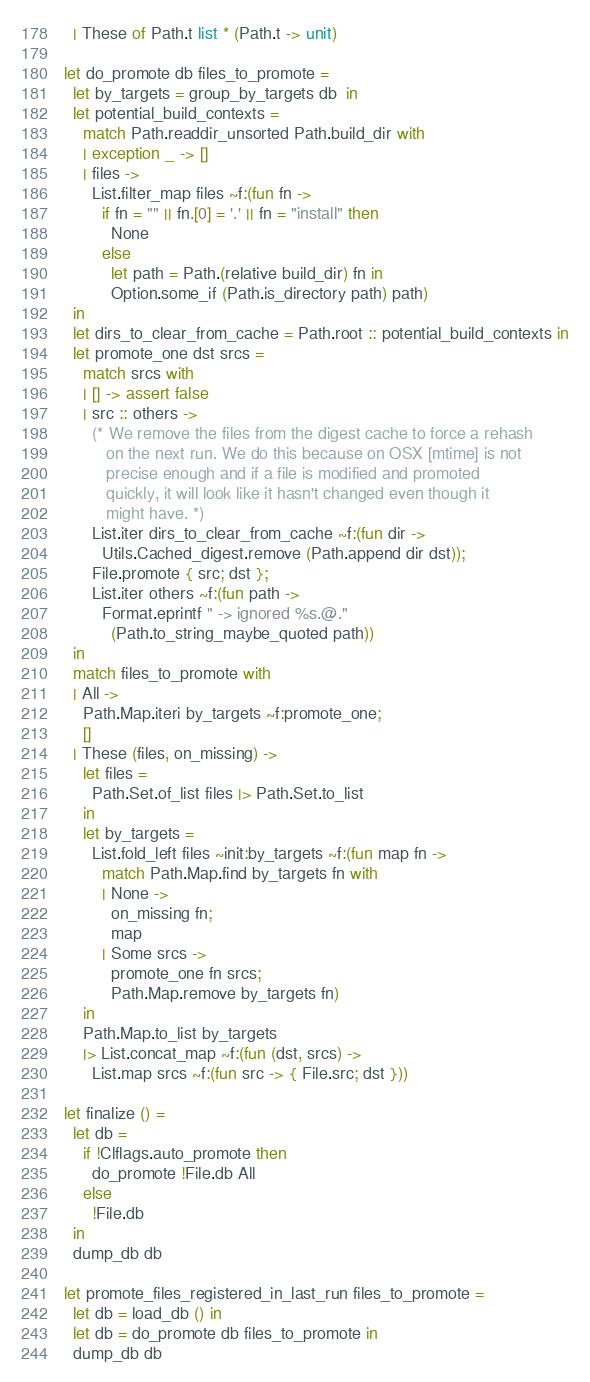<code> <loc_0><loc_0><loc_500><loc_500><_OCaml_>  | These of Path.t list * (Path.t -> unit)

let do_promote db files_to_promote =
  let by_targets = group_by_targets db  in
  let potential_build_contexts =
    match Path.readdir_unsorted Path.build_dir with
    | exception _ -> []
    | files ->
      List.filter_map files ~f:(fun fn ->
        if fn = "" || fn.[0] = '.' || fn = "install" then
          None
        else
          let path = Path.(relative build_dir) fn in
          Option.some_if (Path.is_directory path) path)
  in
  let dirs_to_clear_from_cache = Path.root :: potential_build_contexts in
  let promote_one dst srcs =
    match srcs with
    | [] -> assert false
    | src :: others ->
      (* We remove the files from the digest cache to force a rehash
         on the next run. We do this because on OSX [mtime] is not
         precise enough and if a file is modified and promoted
         quickly, it will look like it hasn't changed even though it
         might have. *)
      List.iter dirs_to_clear_from_cache ~f:(fun dir ->
        Utils.Cached_digest.remove (Path.append dir dst));
      File.promote { src; dst };
      List.iter others ~f:(fun path ->
        Format.eprintf " -> ignored %s.@."
          (Path.to_string_maybe_quoted path))
  in
  match files_to_promote with
  | All ->
    Path.Map.iteri by_targets ~f:promote_one;
    []
  | These (files, on_missing) ->
    let files =
      Path.Set.of_list files |> Path.Set.to_list
    in
    let by_targets =
      List.fold_left files ~init:by_targets ~f:(fun map fn ->
        match Path.Map.find by_targets fn with
        | None ->
          on_missing fn;
          map
        | Some srcs ->
          promote_one fn srcs;
          Path.Map.remove by_targets fn)
    in
    Path.Map.to_list by_targets
    |> List.concat_map ~f:(fun (dst, srcs) ->
      List.map srcs ~f:(fun src -> { File.src; dst }))

let finalize () =
  let db =
    if !Clflags.auto_promote then
      do_promote !File.db All
    else
      !File.db
  in
  dump_db db

let promote_files_registered_in_last_run files_to_promote =
  let db = load_db () in
  let db = do_promote db files_to_promote in
  dump_db db
</code> 